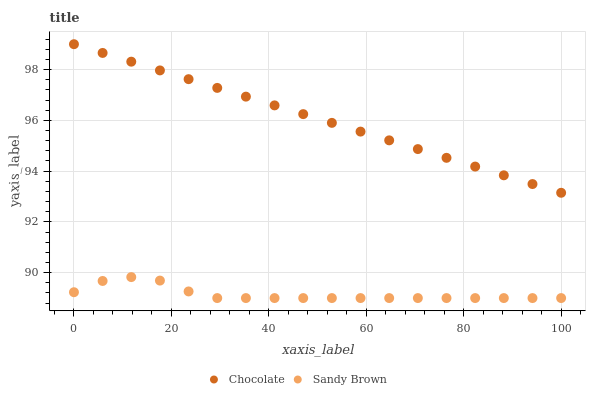Does Sandy Brown have the minimum area under the curve?
Answer yes or no. Yes. Does Chocolate have the maximum area under the curve?
Answer yes or no. Yes. Does Chocolate have the minimum area under the curve?
Answer yes or no. No. Is Chocolate the smoothest?
Answer yes or no. Yes. Is Sandy Brown the roughest?
Answer yes or no. Yes. Is Chocolate the roughest?
Answer yes or no. No. Does Sandy Brown have the lowest value?
Answer yes or no. Yes. Does Chocolate have the lowest value?
Answer yes or no. No. Does Chocolate have the highest value?
Answer yes or no. Yes. Is Sandy Brown less than Chocolate?
Answer yes or no. Yes. Is Chocolate greater than Sandy Brown?
Answer yes or no. Yes. Does Sandy Brown intersect Chocolate?
Answer yes or no. No. 